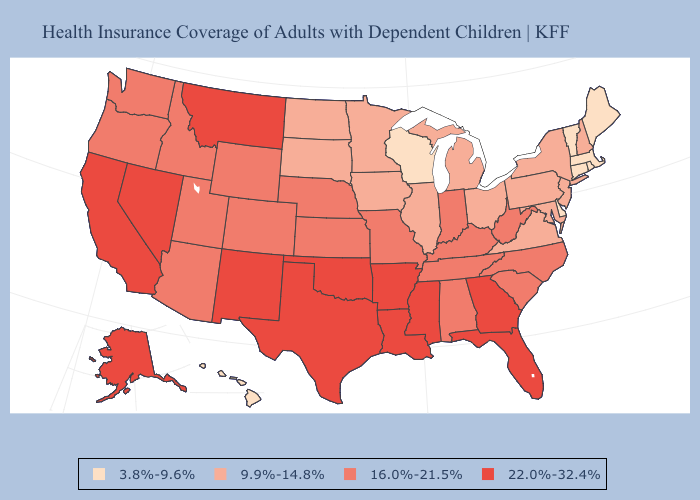What is the lowest value in states that border West Virginia?
Be succinct. 9.9%-14.8%. Name the states that have a value in the range 16.0%-21.5%?
Answer briefly. Alabama, Arizona, Colorado, Idaho, Indiana, Kansas, Kentucky, Missouri, Nebraska, North Carolina, Oregon, South Carolina, Tennessee, Utah, Washington, West Virginia, Wyoming. Name the states that have a value in the range 9.9%-14.8%?
Quick response, please. Illinois, Iowa, Maryland, Michigan, Minnesota, New Hampshire, New Jersey, New York, North Dakota, Ohio, Pennsylvania, South Dakota, Virginia. Among the states that border Kansas , does Nebraska have the highest value?
Write a very short answer. No. How many symbols are there in the legend?
Give a very brief answer. 4. Among the states that border West Virginia , which have the lowest value?
Quick response, please. Maryland, Ohio, Pennsylvania, Virginia. Does the first symbol in the legend represent the smallest category?
Answer briefly. Yes. What is the value of Texas?
Answer briefly. 22.0%-32.4%. Among the states that border Iowa , which have the lowest value?
Concise answer only. Wisconsin. Name the states that have a value in the range 3.8%-9.6%?
Concise answer only. Connecticut, Delaware, Hawaii, Maine, Massachusetts, Rhode Island, Vermont, Wisconsin. Name the states that have a value in the range 9.9%-14.8%?
Be succinct. Illinois, Iowa, Maryland, Michigan, Minnesota, New Hampshire, New Jersey, New York, North Dakota, Ohio, Pennsylvania, South Dakota, Virginia. Does New Hampshire have the highest value in the Northeast?
Short answer required. Yes. What is the value of Illinois?
Answer briefly. 9.9%-14.8%. 